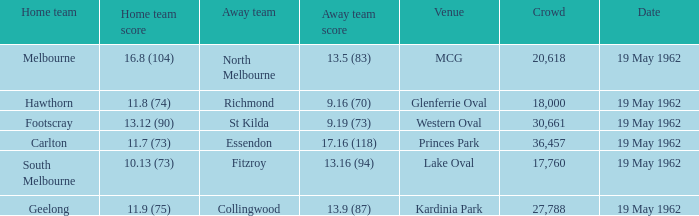8 (104)? 13.5 (83). Help me parse the entirety of this table. {'header': ['Home team', 'Home team score', 'Away team', 'Away team score', 'Venue', 'Crowd', 'Date'], 'rows': [['Melbourne', '16.8 (104)', 'North Melbourne', '13.5 (83)', 'MCG', '20,618', '19 May 1962'], ['Hawthorn', '11.8 (74)', 'Richmond', '9.16 (70)', 'Glenferrie Oval', '18,000', '19 May 1962'], ['Footscray', '13.12 (90)', 'St Kilda', '9.19 (73)', 'Western Oval', '30,661', '19 May 1962'], ['Carlton', '11.7 (73)', 'Essendon', '17.16 (118)', 'Princes Park', '36,457', '19 May 1962'], ['South Melbourne', '10.13 (73)', 'Fitzroy', '13.16 (94)', 'Lake Oval', '17,760', '19 May 1962'], ['Geelong', '11.9 (75)', 'Collingwood', '13.9 (87)', 'Kardinia Park', '27,788', '19 May 1962']]} 